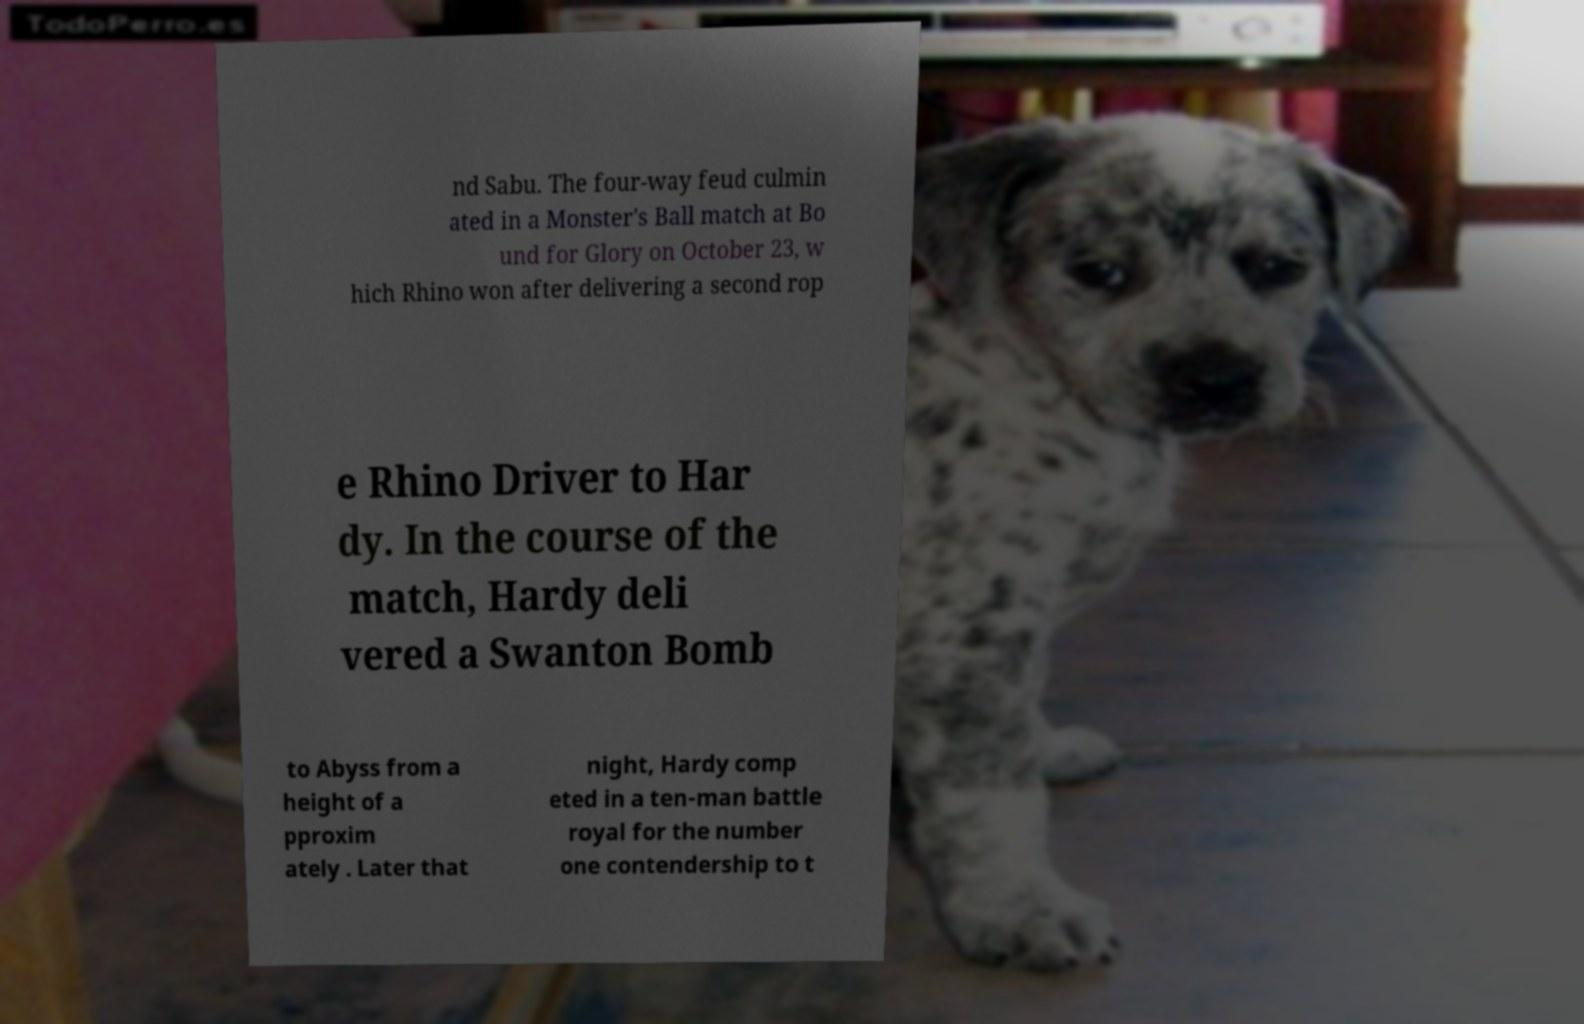What messages or text are displayed in this image? I need them in a readable, typed format. nd Sabu. The four-way feud culmin ated in a Monster's Ball match at Bo und for Glory on October 23, w hich Rhino won after delivering a second rop e Rhino Driver to Har dy. In the course of the match, Hardy deli vered a Swanton Bomb to Abyss from a height of a pproxim ately . Later that night, Hardy comp eted in a ten-man battle royal for the number one contendership to t 